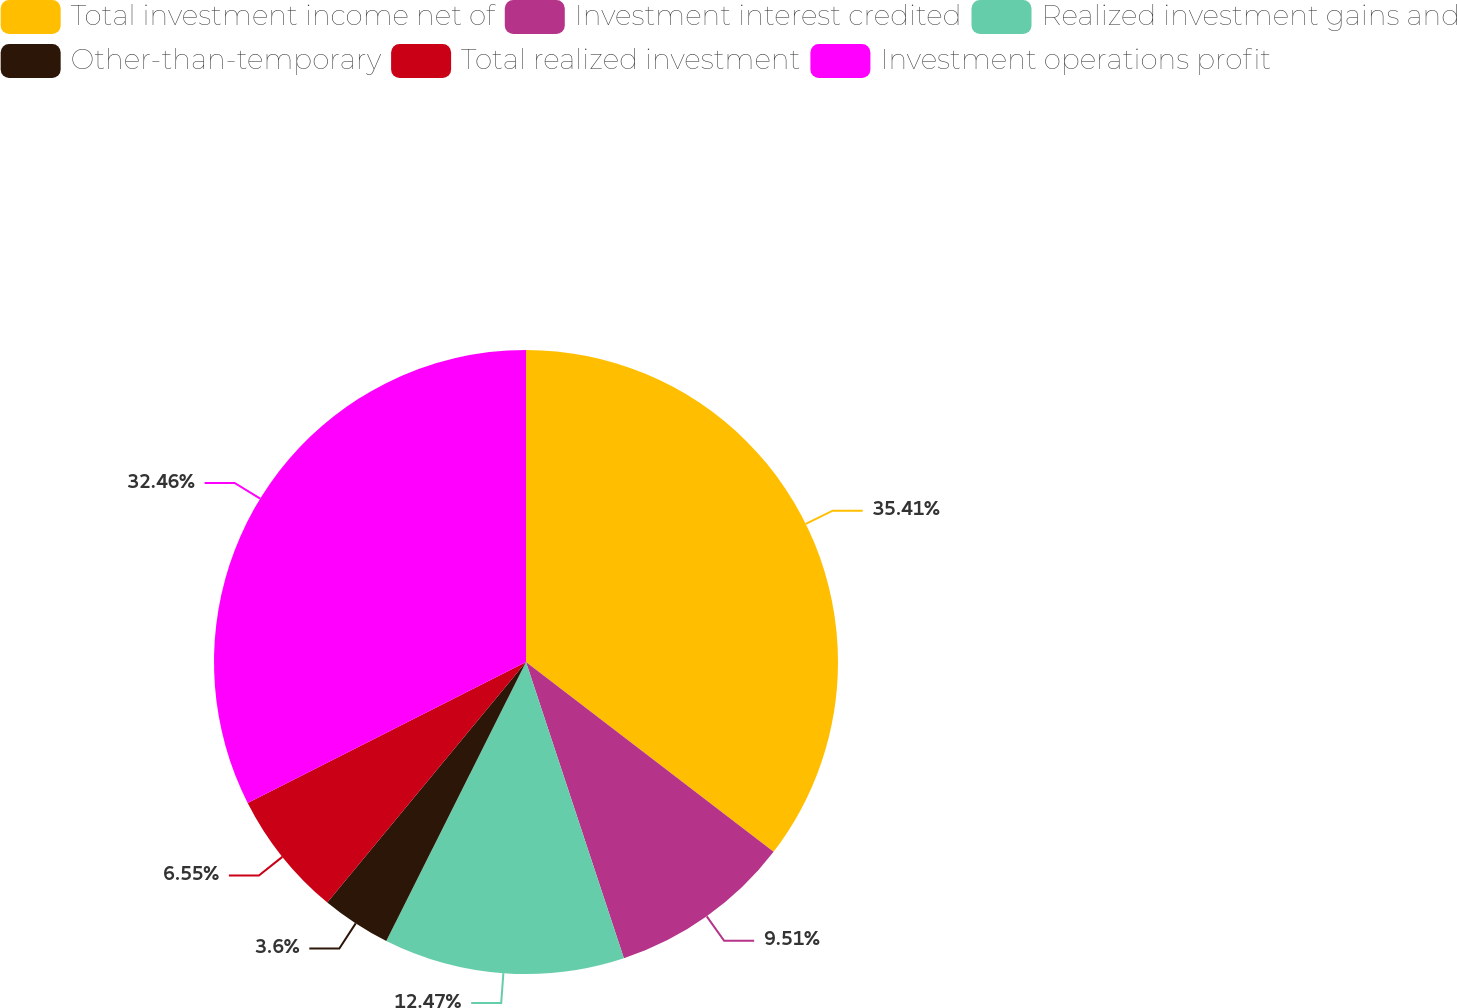Convert chart to OTSL. <chart><loc_0><loc_0><loc_500><loc_500><pie_chart><fcel>Total investment income net of<fcel>Investment interest credited<fcel>Realized investment gains and<fcel>Other-than-temporary<fcel>Total realized investment<fcel>Investment operations profit<nl><fcel>35.41%<fcel>9.51%<fcel>12.47%<fcel>3.6%<fcel>6.55%<fcel>32.46%<nl></chart> 